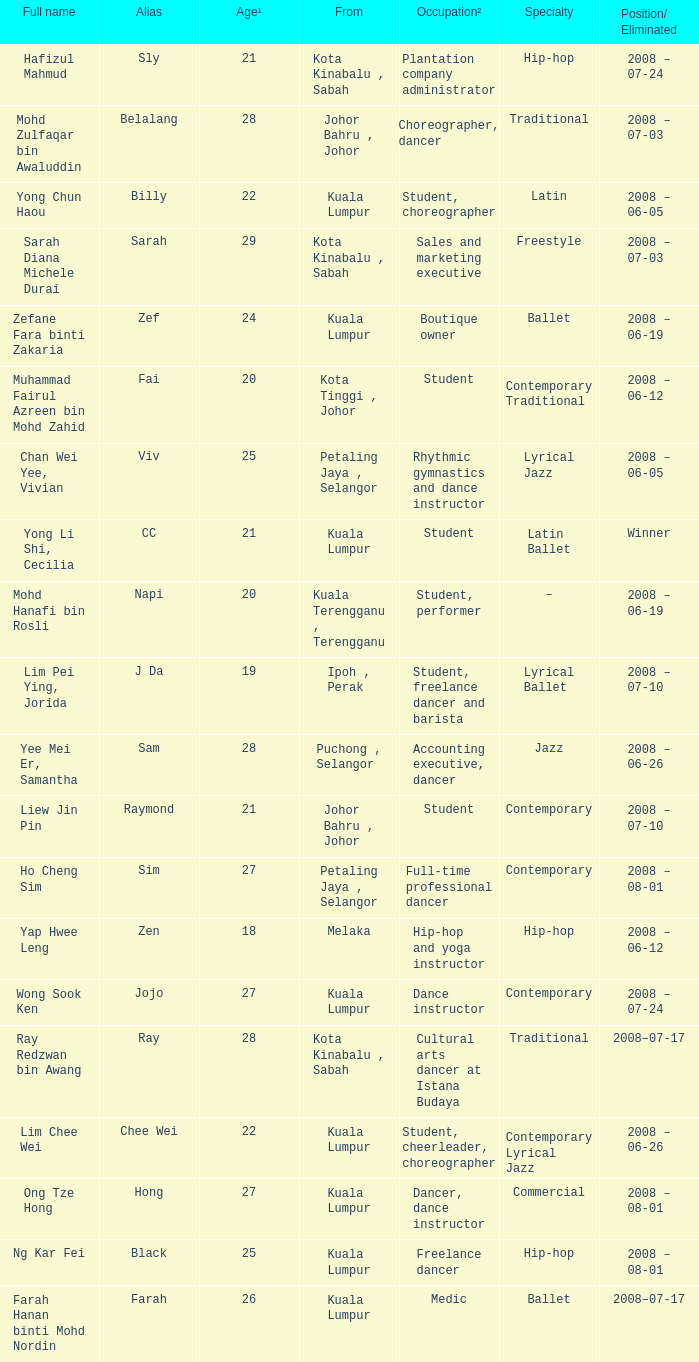What is Occupation², when Age¹ is greater than 24, when Alias is "Black"? Freelance dancer. 